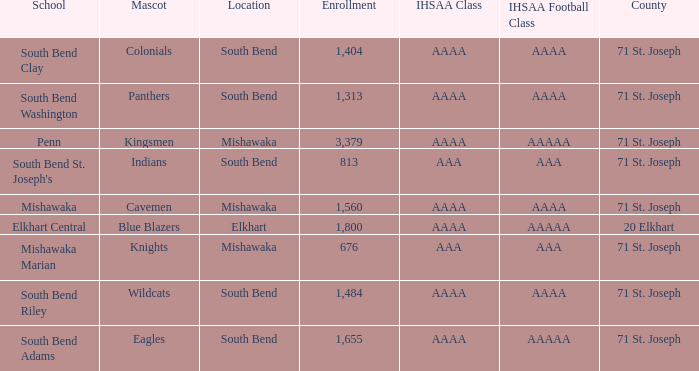What IHSAA Football Class has 20 elkhart as the county? AAAAA. 